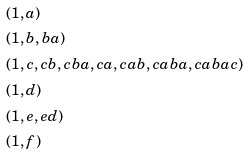<formula> <loc_0><loc_0><loc_500><loc_500>& ( 1 , a ) \\ & ( 1 , b , b a ) \\ & ( 1 , c , c b , c b a , c a , c a b , c a b a , c a b a c ) \\ & ( 1 , d ) \\ & ( 1 , e , e d ) \\ & ( 1 , f )</formula> 